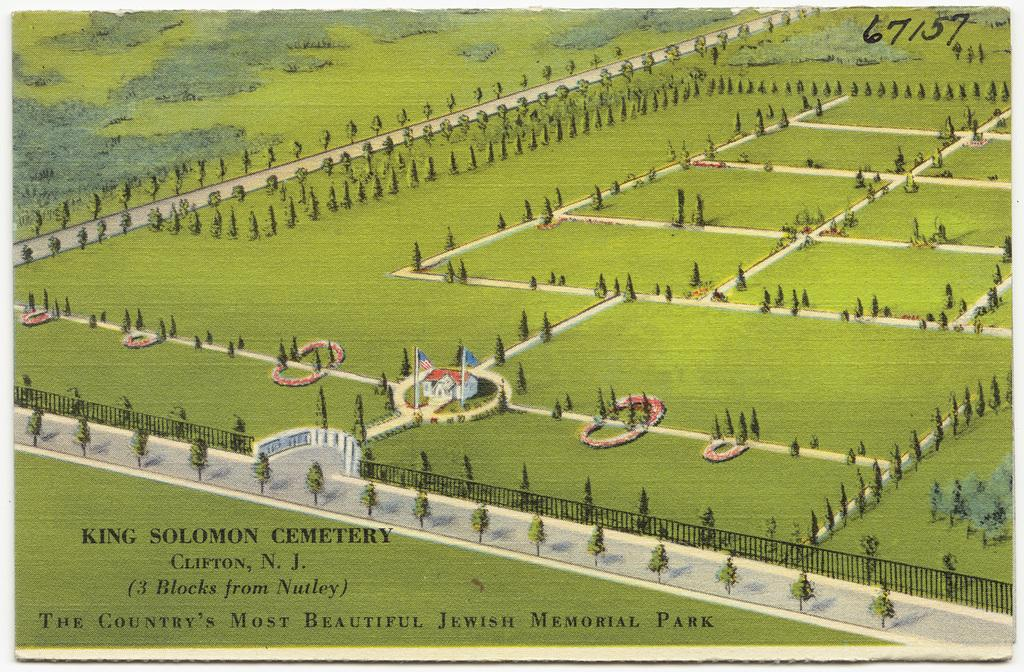<image>
Share a concise interpretation of the image provided. A postcard features an image of King Solomon Cemetery. 